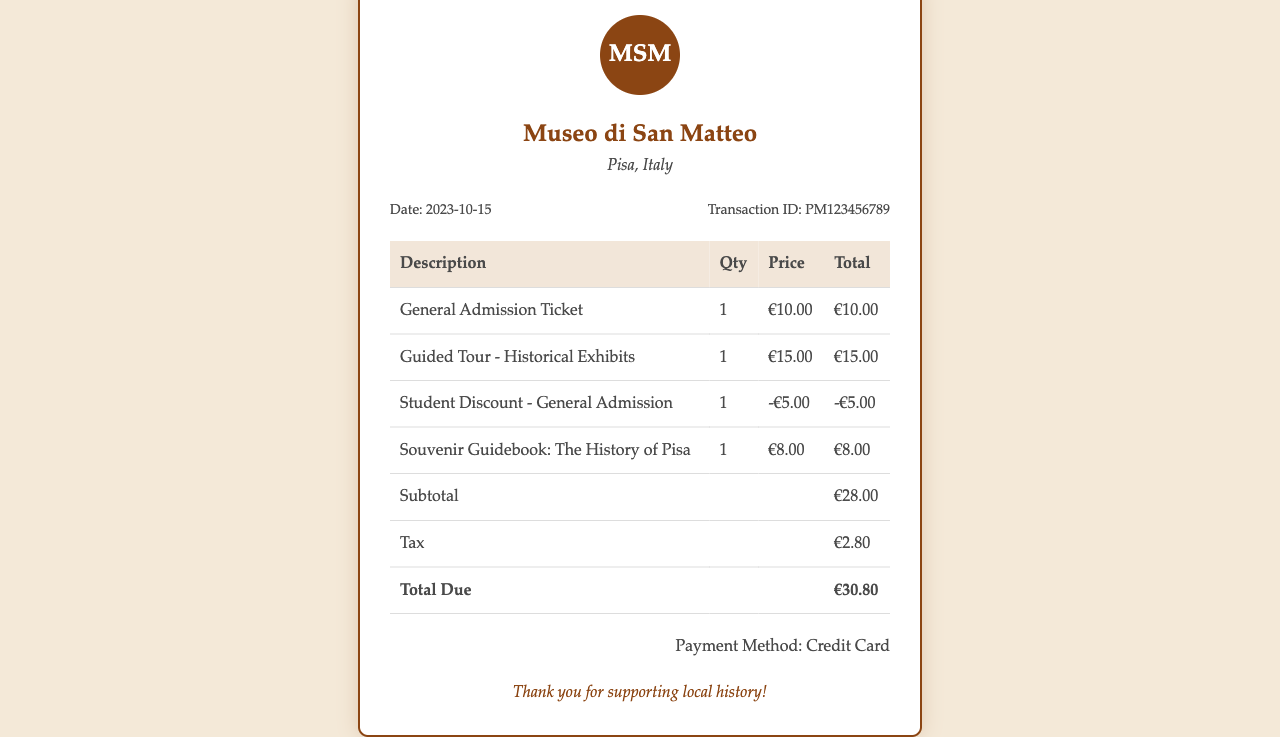What is the date of the transaction? The date of the transaction is explicitly stated in the document under transaction info.
Answer: 2023-10-15 What is the transaction ID? The transaction ID is provided in the document, indicating a unique reference for the transaction.
Answer: PM123456789 How much is the General Admission Ticket? The price for the General Admission Ticket is directly listed in the itemized section.
Answer: €10.00 What is the total due amount? The total due amount is calculated and presented at the end of the itemized table.
Answer: €30.80 What discount is applied for the Student Admission? The document shows a specific entry for the discount associated with the student admission.
Answer: -€5.00 How many tickets were purchased in total? By adding the quantities of each ticket purchase in the itemized list, we can determine the total tickets bought.
Answer: 3 What payment method was used? The payment method is stated at the bottom of the receipt, indicating how the transaction was completed.
Answer: Credit Card What is the subtitle of the souvenir guidebook? The souvenir guidebook's title is mentioned in the itemized list, revealing its content.
Answer: The History of Pisa What type of tour is included in the receipt? The type of tour is specified in the itemized list, detailing the experience included with the ticket purchase.
Answer: Guided Tour - Historical Exhibits 